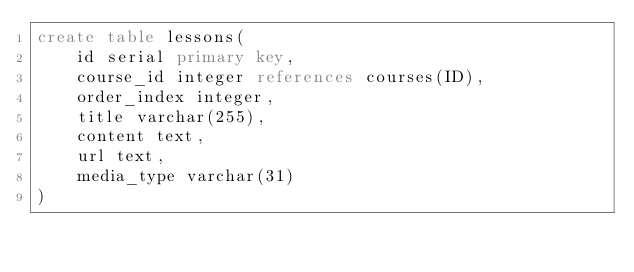<code> <loc_0><loc_0><loc_500><loc_500><_SQL_>create table lessons(
    id serial primary key,
    course_id integer references courses(ID),
    order_index integer,
    title varchar(255),
    content text,
    url text,
    media_type varchar(31)
)</code> 